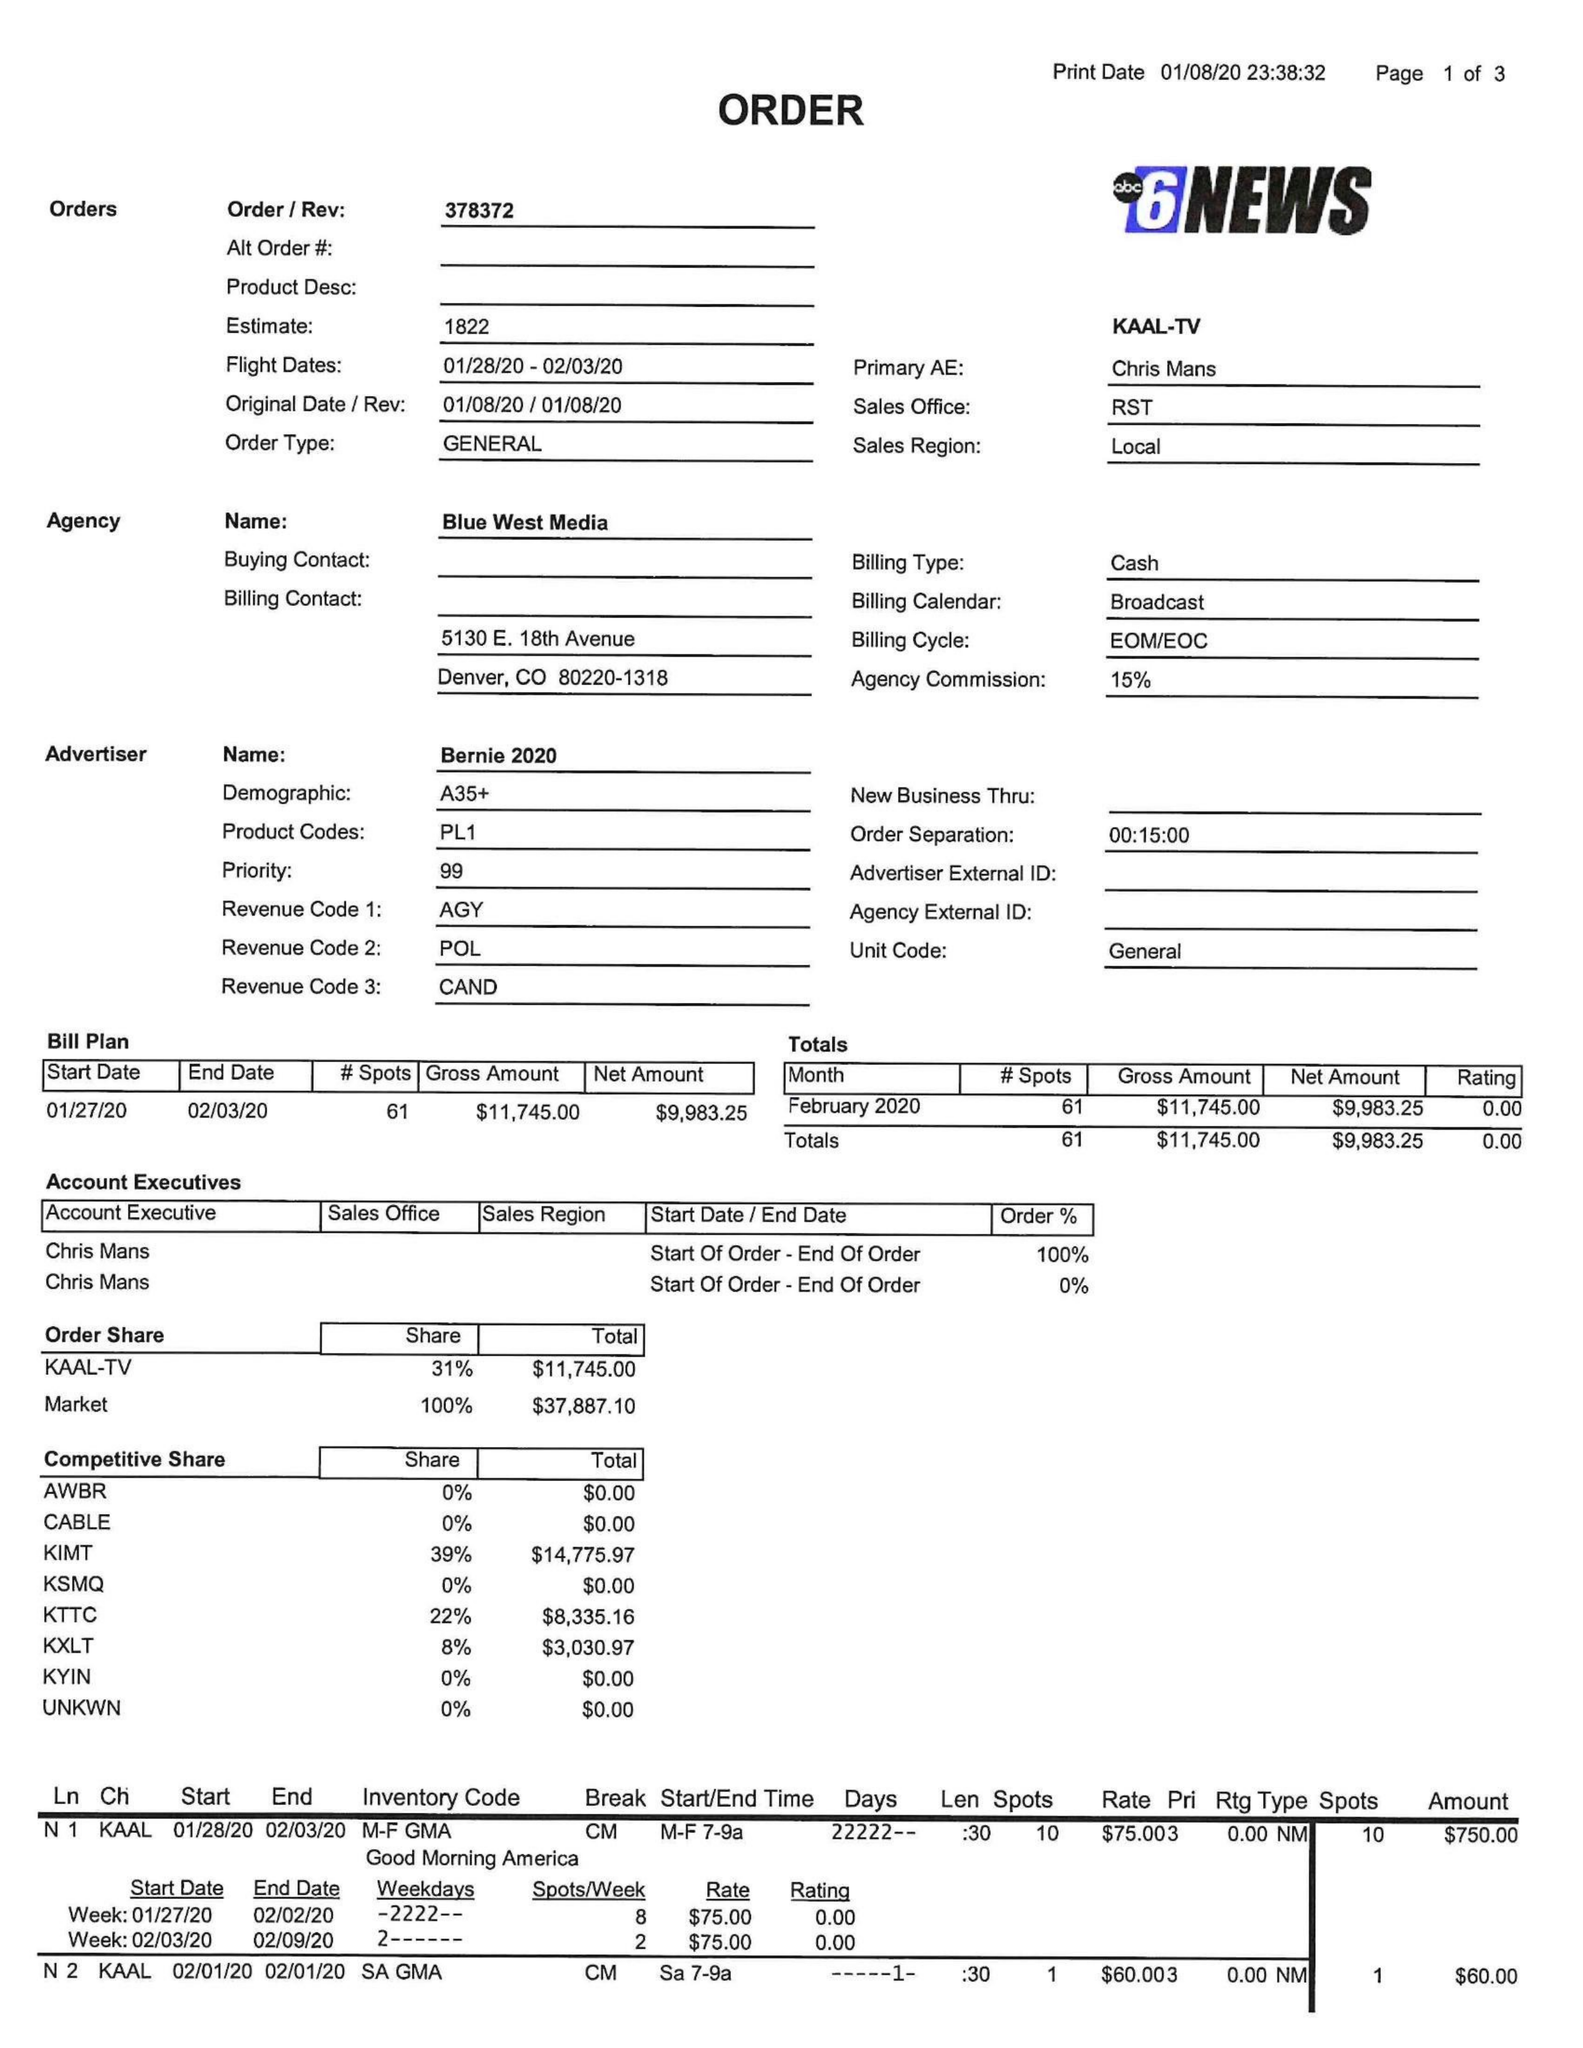What is the value for the flight_to?
Answer the question using a single word or phrase. 02/03/20 